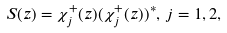<formula> <loc_0><loc_0><loc_500><loc_500>S ( z ) = \chi _ { j } ^ { + } ( z ) ( \chi _ { j } ^ { + } ( z ) ) ^ { * } , \, j = 1 , 2 ,</formula> 